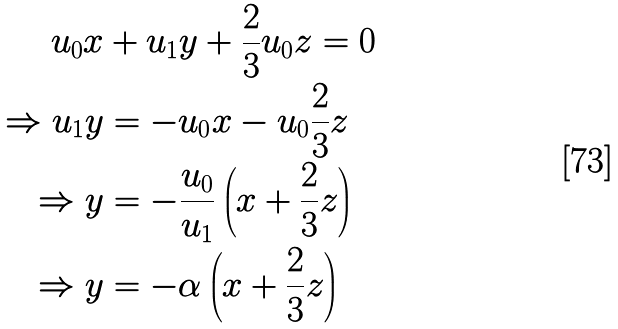Convert formula to latex. <formula><loc_0><loc_0><loc_500><loc_500>u _ { 0 } x & + u _ { 1 } y + \frac { 2 } { 3 } u _ { 0 } z = 0 \\ \Rightarrow u _ { 1 } y & = - u _ { 0 } x - u _ { 0 } \frac { 2 } { 3 } z \\ \Rightarrow y & = - \frac { u _ { 0 } } { u _ { 1 } } \left ( x + \frac { 2 } { 3 } z \right ) \\ \Rightarrow y & = - \alpha \left ( x + \frac { 2 } { 3 } z \right )</formula> 